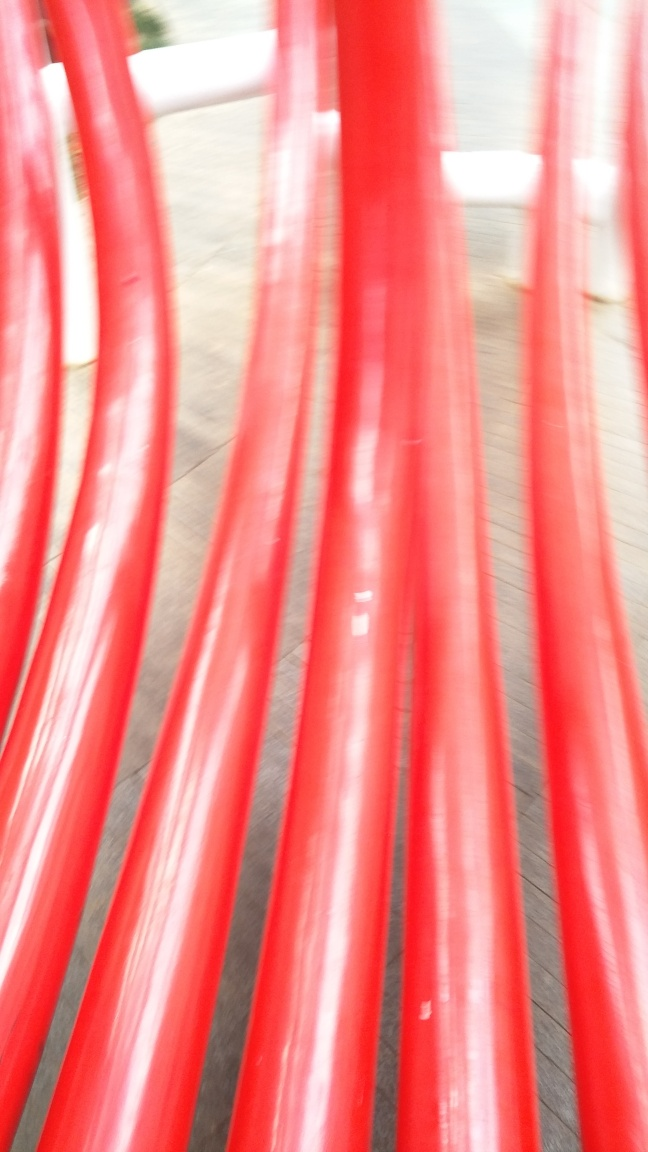Are most of the texture details of the subject retained? Not entirely. The image is noticeably blurry, which significantly reduces the visibility of fine texture details. The red objects appear to be cylindrical in shape, possibly a part of an installation or playground equipment, but the motion blur diminishes the clarity of specific textures that would be visible in a still image. 